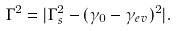Convert formula to latex. <formula><loc_0><loc_0><loc_500><loc_500>\Gamma ^ { 2 } = | \Gamma _ { s } ^ { 2 } - ( \gamma _ { 0 } - \gamma _ { e v } ) ^ { 2 } | .</formula> 